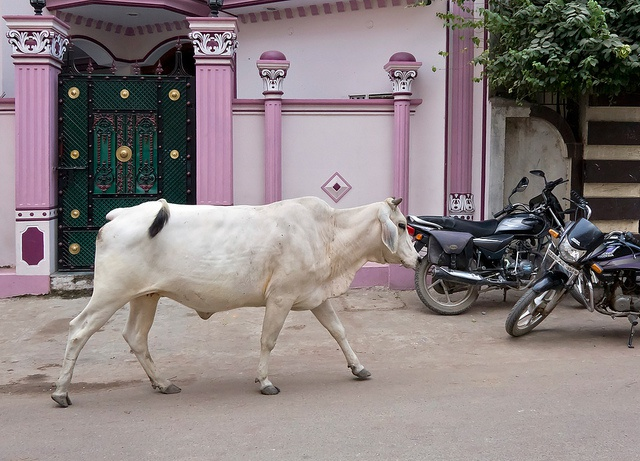Describe the objects in this image and their specific colors. I can see cow in lightgray, darkgray, and gray tones, motorcycle in lightgray, black, gray, and darkgray tones, and motorcycle in lightgray, black, gray, and darkgray tones in this image. 